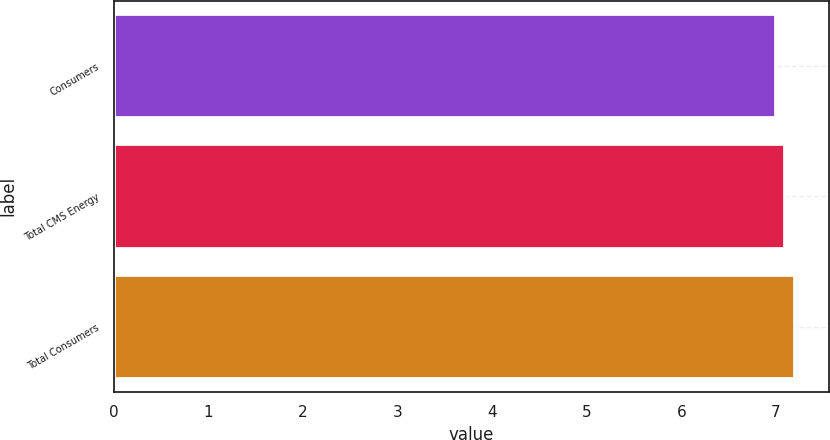<chart> <loc_0><loc_0><loc_500><loc_500><bar_chart><fcel>Consumers<fcel>Total CMS Energy<fcel>Total Consumers<nl><fcel>7<fcel>7.1<fcel>7.2<nl></chart> 